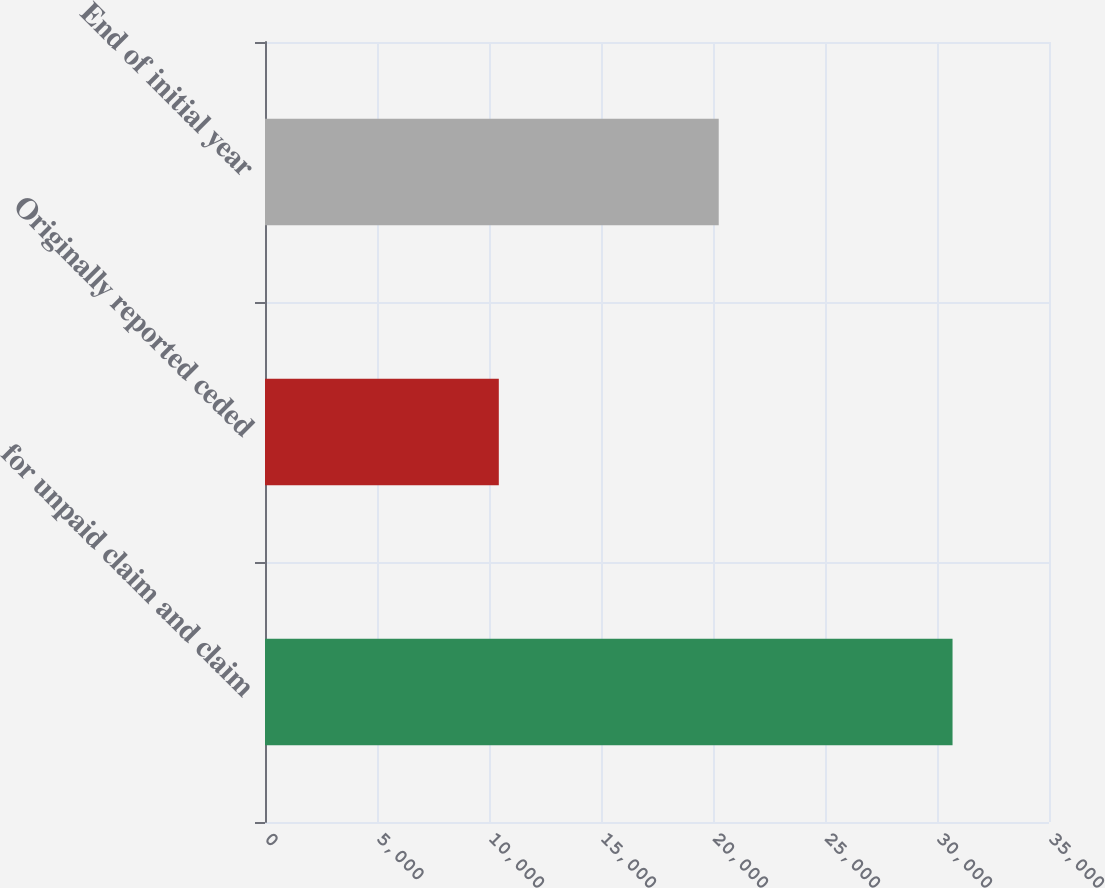Convert chart. <chart><loc_0><loc_0><loc_500><loc_500><bar_chart><fcel>for unpaid claim and claim<fcel>Originally reported ceded<fcel>End of initial year<nl><fcel>30694<fcel>10438<fcel>20256<nl></chart> 